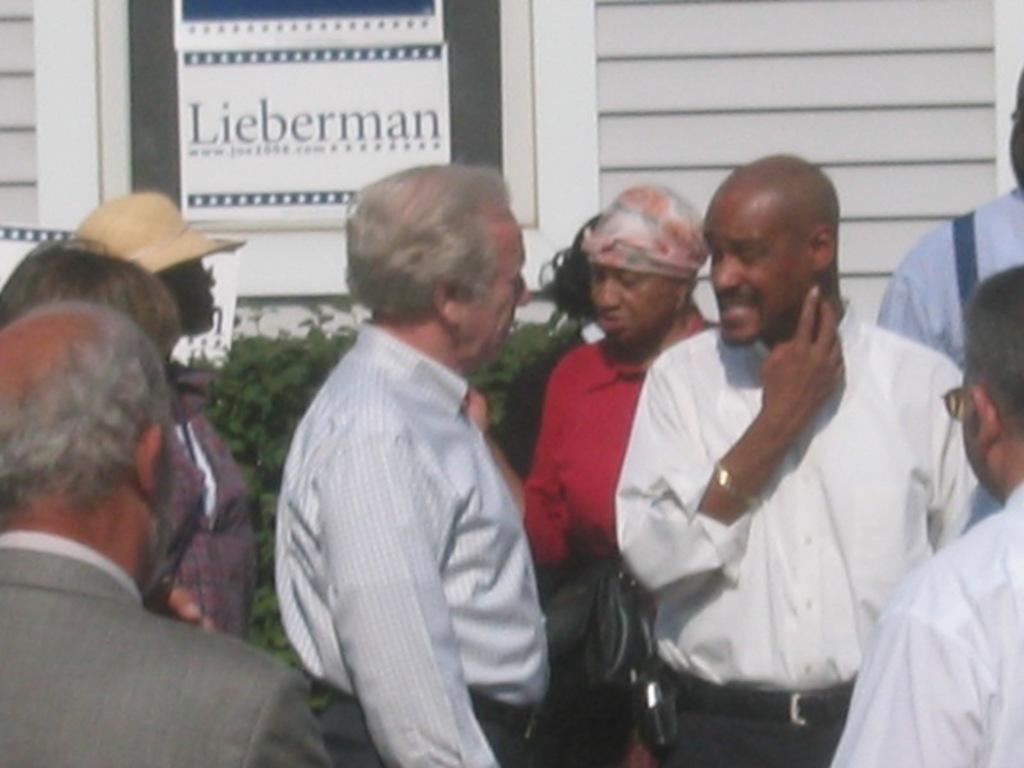Describe this image in one or two sentences. In this image I can see in the middle a man is standing, he wore shirt, trouser. On the right side a man is talking. Behind him there is a woman, she wore a red color t-shirt and there are plants. Behind them it looks like a wooden house. There is a glass window, on that there is a sheet with name on it. 